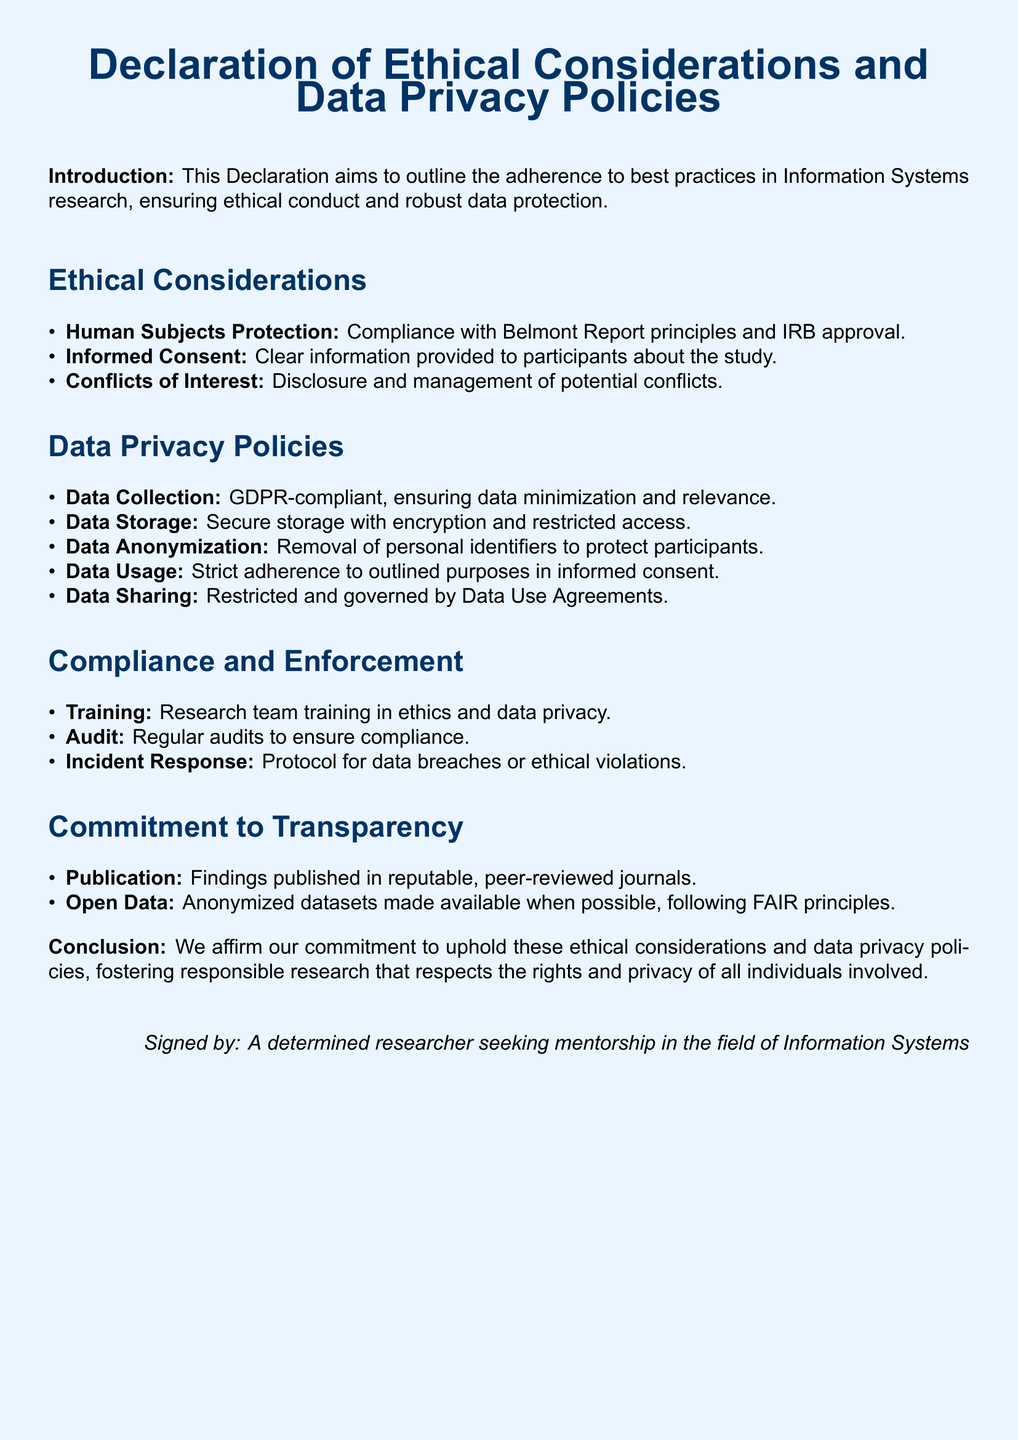What is the title of the document? The title of the document is presented at the beginning and gives the main subject, which is focused on ethical considerations and data privacy policies in research.
Answer: Declaration of Ethical Considerations and Data Privacy Policies How many ethical considerations are listed? The document contains a list of ethical considerations, which can be counted directly from the itemized list.
Answer: 3 What is the purpose of data anonymization mentioned in the document? Data anonymization is emphasized in the document as a critical step to protect participants by removing personal identifiers, ensuring their privacy.
Answer: Protect participants What compliance principle is mentioned for human subjects protection? The document explicitly mentions a well-known guideline that governs the ethical treatment of human subjects in research, which can be identified in the compliance section.
Answer: Belmont Report What is the training focus for the research team? The training required for the research team is detailed in the compliance section of the document, centering on ethics and data privacy.
Answer: Ethics and data privacy How often are audits conducted to ensure compliance? The document specifies that regular audits are part of the compliance process to ensure adherence to the stated ethical considerations and data privacy policies.
Answer: Regularly What is the intention behind making anonymized datasets available? The document indicates a commitment to transparency and openness about research findings, particularly referring to the sharing of data following certain principles.
Answer: Transparency What are the Data Use Agreements related to? This term is referenced in the context of the policies governing how data can be shared, reflecting the restrictions placed on data sharing in the research process.
Answer: Restricted sharing What type of publication is emphasized in the document? The document identifies the type of publication deemed appropriate for disseminating findings, underscoring the importance of reputable sources.
Answer: Peer-reviewed journals 